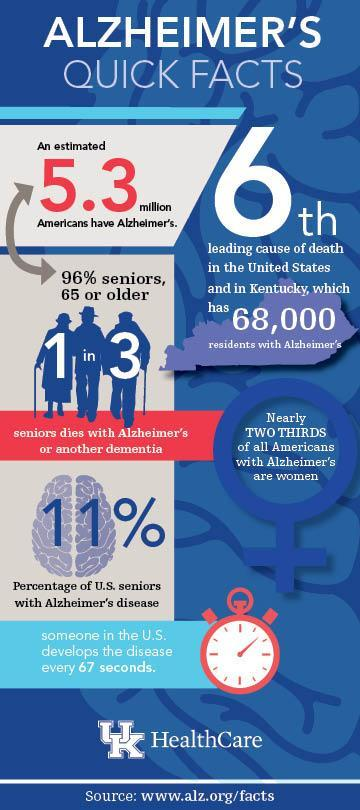Of the 5.3 million affected, how many are 65 or older
Answer the question with a short phrase. 96% how many in US delevelops Alzhemiers in every 2 minutes 2 What is the percentage of U.S. seniors who are not affected with the Alzheimer's disease? 89% How many residents in US and Kentucky have Alzheimer's disease? 68,000 What is the colour of then clock dial, red or white white 